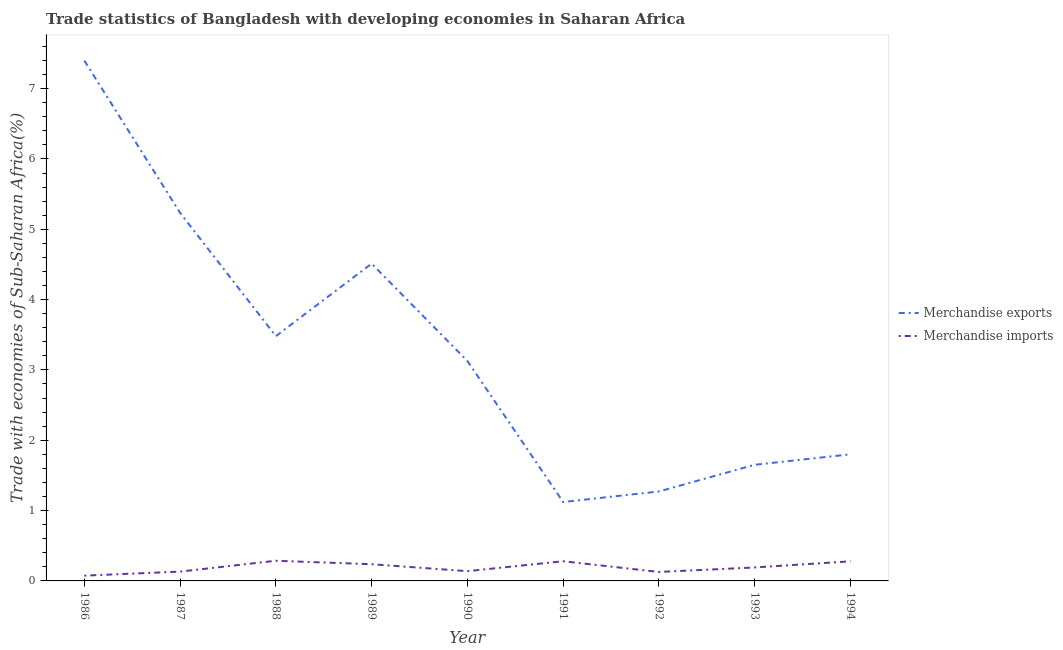How many different coloured lines are there?
Your response must be concise. 2. Does the line corresponding to merchandise imports intersect with the line corresponding to merchandise exports?
Offer a very short reply. No. What is the merchandise imports in 1992?
Offer a very short reply. 0.13. Across all years, what is the maximum merchandise imports?
Make the answer very short. 0.29. Across all years, what is the minimum merchandise imports?
Make the answer very short. 0.08. In which year was the merchandise imports maximum?
Your answer should be compact. 1988. In which year was the merchandise imports minimum?
Make the answer very short. 1986. What is the total merchandise imports in the graph?
Ensure brevity in your answer.  1.75. What is the difference between the merchandise imports in 1989 and that in 1990?
Offer a terse response. 0.1. What is the difference between the merchandise exports in 1988 and the merchandise imports in 1990?
Provide a short and direct response. 3.34. What is the average merchandise exports per year?
Your answer should be compact. 3.29. In the year 1988, what is the difference between the merchandise imports and merchandise exports?
Provide a short and direct response. -3.19. In how many years, is the merchandise imports greater than 1.8 %?
Make the answer very short. 0. What is the ratio of the merchandise exports in 1987 to that in 1988?
Your answer should be very brief. 1.5. Is the merchandise exports in 1990 less than that in 1994?
Your response must be concise. No. Is the difference between the merchandise imports in 1987 and 1993 greater than the difference between the merchandise exports in 1987 and 1993?
Provide a short and direct response. No. What is the difference between the highest and the second highest merchandise exports?
Provide a short and direct response. 2.16. What is the difference between the highest and the lowest merchandise imports?
Offer a very short reply. 0.21. In how many years, is the merchandise imports greater than the average merchandise imports taken over all years?
Ensure brevity in your answer.  4. Is the merchandise imports strictly greater than the merchandise exports over the years?
Ensure brevity in your answer.  No. What is the difference between two consecutive major ticks on the Y-axis?
Provide a short and direct response. 1. Where does the legend appear in the graph?
Your answer should be compact. Center right. How are the legend labels stacked?
Your answer should be compact. Vertical. What is the title of the graph?
Your answer should be very brief. Trade statistics of Bangladesh with developing economies in Saharan Africa. Does "Non-solid fuel" appear as one of the legend labels in the graph?
Ensure brevity in your answer.  No. What is the label or title of the X-axis?
Offer a terse response. Year. What is the label or title of the Y-axis?
Offer a very short reply. Trade with economies of Sub-Saharan Africa(%). What is the Trade with economies of Sub-Saharan Africa(%) of Merchandise exports in 1986?
Provide a short and direct response. 7.4. What is the Trade with economies of Sub-Saharan Africa(%) of Merchandise imports in 1986?
Give a very brief answer. 0.08. What is the Trade with economies of Sub-Saharan Africa(%) of Merchandise exports in 1987?
Provide a short and direct response. 5.23. What is the Trade with economies of Sub-Saharan Africa(%) in Merchandise imports in 1987?
Your answer should be very brief. 0.13. What is the Trade with economies of Sub-Saharan Africa(%) in Merchandise exports in 1988?
Give a very brief answer. 3.48. What is the Trade with economies of Sub-Saharan Africa(%) in Merchandise imports in 1988?
Your response must be concise. 0.29. What is the Trade with economies of Sub-Saharan Africa(%) of Merchandise exports in 1989?
Your answer should be compact. 4.51. What is the Trade with economies of Sub-Saharan Africa(%) of Merchandise imports in 1989?
Keep it short and to the point. 0.24. What is the Trade with economies of Sub-Saharan Africa(%) in Merchandise exports in 1990?
Make the answer very short. 3.13. What is the Trade with economies of Sub-Saharan Africa(%) in Merchandise imports in 1990?
Provide a succinct answer. 0.14. What is the Trade with economies of Sub-Saharan Africa(%) in Merchandise exports in 1991?
Provide a short and direct response. 1.12. What is the Trade with economies of Sub-Saharan Africa(%) in Merchandise imports in 1991?
Ensure brevity in your answer.  0.28. What is the Trade with economies of Sub-Saharan Africa(%) in Merchandise exports in 1992?
Offer a terse response. 1.27. What is the Trade with economies of Sub-Saharan Africa(%) in Merchandise imports in 1992?
Make the answer very short. 0.13. What is the Trade with economies of Sub-Saharan Africa(%) in Merchandise exports in 1993?
Keep it short and to the point. 1.65. What is the Trade with economies of Sub-Saharan Africa(%) in Merchandise imports in 1993?
Keep it short and to the point. 0.19. What is the Trade with economies of Sub-Saharan Africa(%) of Merchandise exports in 1994?
Your answer should be very brief. 1.8. What is the Trade with economies of Sub-Saharan Africa(%) of Merchandise imports in 1994?
Give a very brief answer. 0.28. Across all years, what is the maximum Trade with economies of Sub-Saharan Africa(%) of Merchandise exports?
Make the answer very short. 7.4. Across all years, what is the maximum Trade with economies of Sub-Saharan Africa(%) of Merchandise imports?
Your answer should be very brief. 0.29. Across all years, what is the minimum Trade with economies of Sub-Saharan Africa(%) of Merchandise exports?
Your response must be concise. 1.12. Across all years, what is the minimum Trade with economies of Sub-Saharan Africa(%) of Merchandise imports?
Offer a terse response. 0.08. What is the total Trade with economies of Sub-Saharan Africa(%) of Merchandise exports in the graph?
Your answer should be very brief. 29.6. What is the total Trade with economies of Sub-Saharan Africa(%) of Merchandise imports in the graph?
Keep it short and to the point. 1.75. What is the difference between the Trade with economies of Sub-Saharan Africa(%) of Merchandise exports in 1986 and that in 1987?
Your answer should be compact. 2.16. What is the difference between the Trade with economies of Sub-Saharan Africa(%) in Merchandise imports in 1986 and that in 1987?
Your answer should be compact. -0.06. What is the difference between the Trade with economies of Sub-Saharan Africa(%) in Merchandise exports in 1986 and that in 1988?
Your response must be concise. 3.92. What is the difference between the Trade with economies of Sub-Saharan Africa(%) of Merchandise imports in 1986 and that in 1988?
Provide a succinct answer. -0.21. What is the difference between the Trade with economies of Sub-Saharan Africa(%) of Merchandise exports in 1986 and that in 1989?
Your response must be concise. 2.89. What is the difference between the Trade with economies of Sub-Saharan Africa(%) in Merchandise imports in 1986 and that in 1989?
Offer a very short reply. -0.16. What is the difference between the Trade with economies of Sub-Saharan Africa(%) of Merchandise exports in 1986 and that in 1990?
Your response must be concise. 4.27. What is the difference between the Trade with economies of Sub-Saharan Africa(%) of Merchandise imports in 1986 and that in 1990?
Your answer should be compact. -0.06. What is the difference between the Trade with economies of Sub-Saharan Africa(%) of Merchandise exports in 1986 and that in 1991?
Give a very brief answer. 6.28. What is the difference between the Trade with economies of Sub-Saharan Africa(%) in Merchandise imports in 1986 and that in 1991?
Your response must be concise. -0.2. What is the difference between the Trade with economies of Sub-Saharan Africa(%) of Merchandise exports in 1986 and that in 1992?
Your answer should be compact. 6.13. What is the difference between the Trade with economies of Sub-Saharan Africa(%) of Merchandise imports in 1986 and that in 1992?
Provide a short and direct response. -0.05. What is the difference between the Trade with economies of Sub-Saharan Africa(%) of Merchandise exports in 1986 and that in 1993?
Provide a succinct answer. 5.75. What is the difference between the Trade with economies of Sub-Saharan Africa(%) in Merchandise imports in 1986 and that in 1993?
Provide a succinct answer. -0.12. What is the difference between the Trade with economies of Sub-Saharan Africa(%) of Merchandise exports in 1986 and that in 1994?
Provide a short and direct response. 5.6. What is the difference between the Trade with economies of Sub-Saharan Africa(%) of Merchandise imports in 1986 and that in 1994?
Make the answer very short. -0.2. What is the difference between the Trade with economies of Sub-Saharan Africa(%) of Merchandise exports in 1987 and that in 1988?
Your answer should be very brief. 1.75. What is the difference between the Trade with economies of Sub-Saharan Africa(%) of Merchandise imports in 1987 and that in 1988?
Offer a very short reply. -0.15. What is the difference between the Trade with economies of Sub-Saharan Africa(%) in Merchandise exports in 1987 and that in 1989?
Provide a succinct answer. 0.72. What is the difference between the Trade with economies of Sub-Saharan Africa(%) of Merchandise imports in 1987 and that in 1989?
Keep it short and to the point. -0.1. What is the difference between the Trade with economies of Sub-Saharan Africa(%) of Merchandise exports in 1987 and that in 1990?
Your response must be concise. 2.11. What is the difference between the Trade with economies of Sub-Saharan Africa(%) in Merchandise imports in 1987 and that in 1990?
Your response must be concise. -0.01. What is the difference between the Trade with economies of Sub-Saharan Africa(%) in Merchandise exports in 1987 and that in 1991?
Make the answer very short. 4.11. What is the difference between the Trade with economies of Sub-Saharan Africa(%) of Merchandise imports in 1987 and that in 1991?
Keep it short and to the point. -0.15. What is the difference between the Trade with economies of Sub-Saharan Africa(%) in Merchandise exports in 1987 and that in 1992?
Give a very brief answer. 3.96. What is the difference between the Trade with economies of Sub-Saharan Africa(%) of Merchandise imports in 1987 and that in 1992?
Your answer should be compact. 0.01. What is the difference between the Trade with economies of Sub-Saharan Africa(%) in Merchandise exports in 1987 and that in 1993?
Provide a succinct answer. 3.58. What is the difference between the Trade with economies of Sub-Saharan Africa(%) in Merchandise imports in 1987 and that in 1993?
Give a very brief answer. -0.06. What is the difference between the Trade with economies of Sub-Saharan Africa(%) in Merchandise exports in 1987 and that in 1994?
Offer a very short reply. 3.43. What is the difference between the Trade with economies of Sub-Saharan Africa(%) in Merchandise imports in 1987 and that in 1994?
Ensure brevity in your answer.  -0.15. What is the difference between the Trade with economies of Sub-Saharan Africa(%) in Merchandise exports in 1988 and that in 1989?
Offer a terse response. -1.03. What is the difference between the Trade with economies of Sub-Saharan Africa(%) in Merchandise imports in 1988 and that in 1989?
Offer a terse response. 0.05. What is the difference between the Trade with economies of Sub-Saharan Africa(%) in Merchandise exports in 1988 and that in 1990?
Give a very brief answer. 0.35. What is the difference between the Trade with economies of Sub-Saharan Africa(%) of Merchandise imports in 1988 and that in 1990?
Offer a very short reply. 0.15. What is the difference between the Trade with economies of Sub-Saharan Africa(%) in Merchandise exports in 1988 and that in 1991?
Offer a very short reply. 2.36. What is the difference between the Trade with economies of Sub-Saharan Africa(%) of Merchandise imports in 1988 and that in 1991?
Keep it short and to the point. 0.01. What is the difference between the Trade with economies of Sub-Saharan Africa(%) in Merchandise exports in 1988 and that in 1992?
Your response must be concise. 2.21. What is the difference between the Trade with economies of Sub-Saharan Africa(%) of Merchandise imports in 1988 and that in 1992?
Provide a short and direct response. 0.16. What is the difference between the Trade with economies of Sub-Saharan Africa(%) of Merchandise exports in 1988 and that in 1993?
Offer a terse response. 1.83. What is the difference between the Trade with economies of Sub-Saharan Africa(%) of Merchandise imports in 1988 and that in 1993?
Ensure brevity in your answer.  0.1. What is the difference between the Trade with economies of Sub-Saharan Africa(%) of Merchandise exports in 1988 and that in 1994?
Provide a succinct answer. 1.68. What is the difference between the Trade with economies of Sub-Saharan Africa(%) of Merchandise imports in 1988 and that in 1994?
Keep it short and to the point. 0.01. What is the difference between the Trade with economies of Sub-Saharan Africa(%) in Merchandise exports in 1989 and that in 1990?
Make the answer very short. 1.38. What is the difference between the Trade with economies of Sub-Saharan Africa(%) of Merchandise imports in 1989 and that in 1990?
Keep it short and to the point. 0.1. What is the difference between the Trade with economies of Sub-Saharan Africa(%) in Merchandise exports in 1989 and that in 1991?
Provide a succinct answer. 3.39. What is the difference between the Trade with economies of Sub-Saharan Africa(%) of Merchandise imports in 1989 and that in 1991?
Offer a terse response. -0.04. What is the difference between the Trade with economies of Sub-Saharan Africa(%) in Merchandise exports in 1989 and that in 1992?
Offer a terse response. 3.24. What is the difference between the Trade with economies of Sub-Saharan Africa(%) of Merchandise imports in 1989 and that in 1992?
Ensure brevity in your answer.  0.11. What is the difference between the Trade with economies of Sub-Saharan Africa(%) of Merchandise exports in 1989 and that in 1993?
Make the answer very short. 2.86. What is the difference between the Trade with economies of Sub-Saharan Africa(%) in Merchandise imports in 1989 and that in 1993?
Provide a succinct answer. 0.05. What is the difference between the Trade with economies of Sub-Saharan Africa(%) of Merchandise exports in 1989 and that in 1994?
Ensure brevity in your answer.  2.71. What is the difference between the Trade with economies of Sub-Saharan Africa(%) in Merchandise imports in 1989 and that in 1994?
Keep it short and to the point. -0.04. What is the difference between the Trade with economies of Sub-Saharan Africa(%) in Merchandise exports in 1990 and that in 1991?
Ensure brevity in your answer.  2. What is the difference between the Trade with economies of Sub-Saharan Africa(%) of Merchandise imports in 1990 and that in 1991?
Provide a short and direct response. -0.14. What is the difference between the Trade with economies of Sub-Saharan Africa(%) in Merchandise exports in 1990 and that in 1992?
Keep it short and to the point. 1.85. What is the difference between the Trade with economies of Sub-Saharan Africa(%) in Merchandise imports in 1990 and that in 1992?
Provide a succinct answer. 0.01. What is the difference between the Trade with economies of Sub-Saharan Africa(%) in Merchandise exports in 1990 and that in 1993?
Your answer should be very brief. 1.48. What is the difference between the Trade with economies of Sub-Saharan Africa(%) of Merchandise imports in 1990 and that in 1993?
Offer a very short reply. -0.05. What is the difference between the Trade with economies of Sub-Saharan Africa(%) in Merchandise exports in 1990 and that in 1994?
Provide a succinct answer. 1.33. What is the difference between the Trade with economies of Sub-Saharan Africa(%) of Merchandise imports in 1990 and that in 1994?
Keep it short and to the point. -0.14. What is the difference between the Trade with economies of Sub-Saharan Africa(%) in Merchandise exports in 1991 and that in 1992?
Keep it short and to the point. -0.15. What is the difference between the Trade with economies of Sub-Saharan Africa(%) of Merchandise imports in 1991 and that in 1992?
Ensure brevity in your answer.  0.15. What is the difference between the Trade with economies of Sub-Saharan Africa(%) in Merchandise exports in 1991 and that in 1993?
Offer a terse response. -0.53. What is the difference between the Trade with economies of Sub-Saharan Africa(%) of Merchandise imports in 1991 and that in 1993?
Make the answer very short. 0.09. What is the difference between the Trade with economies of Sub-Saharan Africa(%) in Merchandise exports in 1991 and that in 1994?
Provide a short and direct response. -0.68. What is the difference between the Trade with economies of Sub-Saharan Africa(%) of Merchandise imports in 1991 and that in 1994?
Keep it short and to the point. 0. What is the difference between the Trade with economies of Sub-Saharan Africa(%) of Merchandise exports in 1992 and that in 1993?
Make the answer very short. -0.38. What is the difference between the Trade with economies of Sub-Saharan Africa(%) in Merchandise imports in 1992 and that in 1993?
Keep it short and to the point. -0.06. What is the difference between the Trade with economies of Sub-Saharan Africa(%) of Merchandise exports in 1992 and that in 1994?
Offer a very short reply. -0.53. What is the difference between the Trade with economies of Sub-Saharan Africa(%) in Merchandise imports in 1992 and that in 1994?
Offer a very short reply. -0.15. What is the difference between the Trade with economies of Sub-Saharan Africa(%) of Merchandise exports in 1993 and that in 1994?
Make the answer very short. -0.15. What is the difference between the Trade with economies of Sub-Saharan Africa(%) in Merchandise imports in 1993 and that in 1994?
Provide a short and direct response. -0.09. What is the difference between the Trade with economies of Sub-Saharan Africa(%) of Merchandise exports in 1986 and the Trade with economies of Sub-Saharan Africa(%) of Merchandise imports in 1987?
Offer a terse response. 7.27. What is the difference between the Trade with economies of Sub-Saharan Africa(%) of Merchandise exports in 1986 and the Trade with economies of Sub-Saharan Africa(%) of Merchandise imports in 1988?
Provide a short and direct response. 7.11. What is the difference between the Trade with economies of Sub-Saharan Africa(%) of Merchandise exports in 1986 and the Trade with economies of Sub-Saharan Africa(%) of Merchandise imports in 1989?
Offer a terse response. 7.16. What is the difference between the Trade with economies of Sub-Saharan Africa(%) of Merchandise exports in 1986 and the Trade with economies of Sub-Saharan Africa(%) of Merchandise imports in 1990?
Provide a short and direct response. 7.26. What is the difference between the Trade with economies of Sub-Saharan Africa(%) of Merchandise exports in 1986 and the Trade with economies of Sub-Saharan Africa(%) of Merchandise imports in 1991?
Your answer should be very brief. 7.12. What is the difference between the Trade with economies of Sub-Saharan Africa(%) of Merchandise exports in 1986 and the Trade with economies of Sub-Saharan Africa(%) of Merchandise imports in 1992?
Provide a short and direct response. 7.27. What is the difference between the Trade with economies of Sub-Saharan Africa(%) in Merchandise exports in 1986 and the Trade with economies of Sub-Saharan Africa(%) in Merchandise imports in 1993?
Provide a succinct answer. 7.21. What is the difference between the Trade with economies of Sub-Saharan Africa(%) of Merchandise exports in 1986 and the Trade with economies of Sub-Saharan Africa(%) of Merchandise imports in 1994?
Ensure brevity in your answer.  7.12. What is the difference between the Trade with economies of Sub-Saharan Africa(%) in Merchandise exports in 1987 and the Trade with economies of Sub-Saharan Africa(%) in Merchandise imports in 1988?
Offer a very short reply. 4.95. What is the difference between the Trade with economies of Sub-Saharan Africa(%) in Merchandise exports in 1987 and the Trade with economies of Sub-Saharan Africa(%) in Merchandise imports in 1989?
Your answer should be compact. 5. What is the difference between the Trade with economies of Sub-Saharan Africa(%) in Merchandise exports in 1987 and the Trade with economies of Sub-Saharan Africa(%) in Merchandise imports in 1990?
Provide a short and direct response. 5.09. What is the difference between the Trade with economies of Sub-Saharan Africa(%) in Merchandise exports in 1987 and the Trade with economies of Sub-Saharan Africa(%) in Merchandise imports in 1991?
Provide a succinct answer. 4.95. What is the difference between the Trade with economies of Sub-Saharan Africa(%) in Merchandise exports in 1987 and the Trade with economies of Sub-Saharan Africa(%) in Merchandise imports in 1992?
Your answer should be compact. 5.11. What is the difference between the Trade with economies of Sub-Saharan Africa(%) of Merchandise exports in 1987 and the Trade with economies of Sub-Saharan Africa(%) of Merchandise imports in 1993?
Keep it short and to the point. 5.04. What is the difference between the Trade with economies of Sub-Saharan Africa(%) of Merchandise exports in 1987 and the Trade with economies of Sub-Saharan Africa(%) of Merchandise imports in 1994?
Your answer should be compact. 4.95. What is the difference between the Trade with economies of Sub-Saharan Africa(%) in Merchandise exports in 1988 and the Trade with economies of Sub-Saharan Africa(%) in Merchandise imports in 1989?
Give a very brief answer. 3.24. What is the difference between the Trade with economies of Sub-Saharan Africa(%) in Merchandise exports in 1988 and the Trade with economies of Sub-Saharan Africa(%) in Merchandise imports in 1990?
Your response must be concise. 3.34. What is the difference between the Trade with economies of Sub-Saharan Africa(%) in Merchandise exports in 1988 and the Trade with economies of Sub-Saharan Africa(%) in Merchandise imports in 1991?
Offer a very short reply. 3.2. What is the difference between the Trade with economies of Sub-Saharan Africa(%) of Merchandise exports in 1988 and the Trade with economies of Sub-Saharan Africa(%) of Merchandise imports in 1992?
Your answer should be compact. 3.35. What is the difference between the Trade with economies of Sub-Saharan Africa(%) of Merchandise exports in 1988 and the Trade with economies of Sub-Saharan Africa(%) of Merchandise imports in 1993?
Your answer should be very brief. 3.29. What is the difference between the Trade with economies of Sub-Saharan Africa(%) in Merchandise exports in 1988 and the Trade with economies of Sub-Saharan Africa(%) in Merchandise imports in 1994?
Your answer should be compact. 3.2. What is the difference between the Trade with economies of Sub-Saharan Africa(%) of Merchandise exports in 1989 and the Trade with economies of Sub-Saharan Africa(%) of Merchandise imports in 1990?
Your answer should be compact. 4.37. What is the difference between the Trade with economies of Sub-Saharan Africa(%) in Merchandise exports in 1989 and the Trade with economies of Sub-Saharan Africa(%) in Merchandise imports in 1991?
Give a very brief answer. 4.23. What is the difference between the Trade with economies of Sub-Saharan Africa(%) of Merchandise exports in 1989 and the Trade with economies of Sub-Saharan Africa(%) of Merchandise imports in 1992?
Keep it short and to the point. 4.38. What is the difference between the Trade with economies of Sub-Saharan Africa(%) in Merchandise exports in 1989 and the Trade with economies of Sub-Saharan Africa(%) in Merchandise imports in 1993?
Make the answer very short. 4.32. What is the difference between the Trade with economies of Sub-Saharan Africa(%) of Merchandise exports in 1989 and the Trade with economies of Sub-Saharan Africa(%) of Merchandise imports in 1994?
Provide a succinct answer. 4.23. What is the difference between the Trade with economies of Sub-Saharan Africa(%) of Merchandise exports in 1990 and the Trade with economies of Sub-Saharan Africa(%) of Merchandise imports in 1991?
Offer a terse response. 2.85. What is the difference between the Trade with economies of Sub-Saharan Africa(%) of Merchandise exports in 1990 and the Trade with economies of Sub-Saharan Africa(%) of Merchandise imports in 1992?
Provide a short and direct response. 3. What is the difference between the Trade with economies of Sub-Saharan Africa(%) of Merchandise exports in 1990 and the Trade with economies of Sub-Saharan Africa(%) of Merchandise imports in 1993?
Offer a terse response. 2.94. What is the difference between the Trade with economies of Sub-Saharan Africa(%) of Merchandise exports in 1990 and the Trade with economies of Sub-Saharan Africa(%) of Merchandise imports in 1994?
Offer a very short reply. 2.85. What is the difference between the Trade with economies of Sub-Saharan Africa(%) in Merchandise exports in 1991 and the Trade with economies of Sub-Saharan Africa(%) in Merchandise imports in 1992?
Provide a succinct answer. 0.99. What is the difference between the Trade with economies of Sub-Saharan Africa(%) in Merchandise exports in 1991 and the Trade with economies of Sub-Saharan Africa(%) in Merchandise imports in 1993?
Give a very brief answer. 0.93. What is the difference between the Trade with economies of Sub-Saharan Africa(%) in Merchandise exports in 1991 and the Trade with economies of Sub-Saharan Africa(%) in Merchandise imports in 1994?
Ensure brevity in your answer.  0.84. What is the difference between the Trade with economies of Sub-Saharan Africa(%) in Merchandise exports in 1992 and the Trade with economies of Sub-Saharan Africa(%) in Merchandise imports in 1993?
Your answer should be compact. 1.08. What is the difference between the Trade with economies of Sub-Saharan Africa(%) in Merchandise exports in 1993 and the Trade with economies of Sub-Saharan Africa(%) in Merchandise imports in 1994?
Offer a very short reply. 1.37. What is the average Trade with economies of Sub-Saharan Africa(%) in Merchandise exports per year?
Provide a succinct answer. 3.29. What is the average Trade with economies of Sub-Saharan Africa(%) in Merchandise imports per year?
Ensure brevity in your answer.  0.19. In the year 1986, what is the difference between the Trade with economies of Sub-Saharan Africa(%) of Merchandise exports and Trade with economies of Sub-Saharan Africa(%) of Merchandise imports?
Offer a terse response. 7.32. In the year 1987, what is the difference between the Trade with economies of Sub-Saharan Africa(%) in Merchandise exports and Trade with economies of Sub-Saharan Africa(%) in Merchandise imports?
Your answer should be compact. 5.1. In the year 1988, what is the difference between the Trade with economies of Sub-Saharan Africa(%) of Merchandise exports and Trade with economies of Sub-Saharan Africa(%) of Merchandise imports?
Offer a very short reply. 3.19. In the year 1989, what is the difference between the Trade with economies of Sub-Saharan Africa(%) in Merchandise exports and Trade with economies of Sub-Saharan Africa(%) in Merchandise imports?
Give a very brief answer. 4.27. In the year 1990, what is the difference between the Trade with economies of Sub-Saharan Africa(%) in Merchandise exports and Trade with economies of Sub-Saharan Africa(%) in Merchandise imports?
Provide a short and direct response. 2.99. In the year 1991, what is the difference between the Trade with economies of Sub-Saharan Africa(%) in Merchandise exports and Trade with economies of Sub-Saharan Africa(%) in Merchandise imports?
Provide a succinct answer. 0.84. In the year 1992, what is the difference between the Trade with economies of Sub-Saharan Africa(%) in Merchandise exports and Trade with economies of Sub-Saharan Africa(%) in Merchandise imports?
Keep it short and to the point. 1.14. In the year 1993, what is the difference between the Trade with economies of Sub-Saharan Africa(%) in Merchandise exports and Trade with economies of Sub-Saharan Africa(%) in Merchandise imports?
Your answer should be compact. 1.46. In the year 1994, what is the difference between the Trade with economies of Sub-Saharan Africa(%) in Merchandise exports and Trade with economies of Sub-Saharan Africa(%) in Merchandise imports?
Keep it short and to the point. 1.52. What is the ratio of the Trade with economies of Sub-Saharan Africa(%) in Merchandise exports in 1986 to that in 1987?
Your response must be concise. 1.41. What is the ratio of the Trade with economies of Sub-Saharan Africa(%) in Merchandise imports in 1986 to that in 1987?
Give a very brief answer. 0.57. What is the ratio of the Trade with economies of Sub-Saharan Africa(%) in Merchandise exports in 1986 to that in 1988?
Give a very brief answer. 2.13. What is the ratio of the Trade with economies of Sub-Saharan Africa(%) of Merchandise imports in 1986 to that in 1988?
Your answer should be compact. 0.26. What is the ratio of the Trade with economies of Sub-Saharan Africa(%) in Merchandise exports in 1986 to that in 1989?
Offer a very short reply. 1.64. What is the ratio of the Trade with economies of Sub-Saharan Africa(%) in Merchandise imports in 1986 to that in 1989?
Provide a short and direct response. 0.32. What is the ratio of the Trade with economies of Sub-Saharan Africa(%) in Merchandise exports in 1986 to that in 1990?
Offer a terse response. 2.37. What is the ratio of the Trade with economies of Sub-Saharan Africa(%) in Merchandise imports in 1986 to that in 1990?
Keep it short and to the point. 0.54. What is the ratio of the Trade with economies of Sub-Saharan Africa(%) in Merchandise exports in 1986 to that in 1991?
Keep it short and to the point. 6.59. What is the ratio of the Trade with economies of Sub-Saharan Africa(%) of Merchandise imports in 1986 to that in 1991?
Your answer should be compact. 0.27. What is the ratio of the Trade with economies of Sub-Saharan Africa(%) of Merchandise exports in 1986 to that in 1992?
Your response must be concise. 5.82. What is the ratio of the Trade with economies of Sub-Saharan Africa(%) in Merchandise imports in 1986 to that in 1992?
Provide a short and direct response. 0.59. What is the ratio of the Trade with economies of Sub-Saharan Africa(%) of Merchandise exports in 1986 to that in 1993?
Offer a terse response. 4.48. What is the ratio of the Trade with economies of Sub-Saharan Africa(%) in Merchandise imports in 1986 to that in 1993?
Make the answer very short. 0.39. What is the ratio of the Trade with economies of Sub-Saharan Africa(%) in Merchandise exports in 1986 to that in 1994?
Keep it short and to the point. 4.11. What is the ratio of the Trade with economies of Sub-Saharan Africa(%) in Merchandise imports in 1986 to that in 1994?
Provide a short and direct response. 0.27. What is the ratio of the Trade with economies of Sub-Saharan Africa(%) in Merchandise exports in 1987 to that in 1988?
Provide a short and direct response. 1.5. What is the ratio of the Trade with economies of Sub-Saharan Africa(%) in Merchandise imports in 1987 to that in 1988?
Your response must be concise. 0.46. What is the ratio of the Trade with economies of Sub-Saharan Africa(%) in Merchandise exports in 1987 to that in 1989?
Your response must be concise. 1.16. What is the ratio of the Trade with economies of Sub-Saharan Africa(%) of Merchandise imports in 1987 to that in 1989?
Give a very brief answer. 0.56. What is the ratio of the Trade with economies of Sub-Saharan Africa(%) of Merchandise exports in 1987 to that in 1990?
Ensure brevity in your answer.  1.67. What is the ratio of the Trade with economies of Sub-Saharan Africa(%) of Merchandise imports in 1987 to that in 1990?
Give a very brief answer. 0.95. What is the ratio of the Trade with economies of Sub-Saharan Africa(%) of Merchandise exports in 1987 to that in 1991?
Provide a short and direct response. 4.66. What is the ratio of the Trade with economies of Sub-Saharan Africa(%) in Merchandise imports in 1987 to that in 1991?
Provide a succinct answer. 0.47. What is the ratio of the Trade with economies of Sub-Saharan Africa(%) of Merchandise exports in 1987 to that in 1992?
Your response must be concise. 4.11. What is the ratio of the Trade with economies of Sub-Saharan Africa(%) of Merchandise imports in 1987 to that in 1992?
Your answer should be very brief. 1.04. What is the ratio of the Trade with economies of Sub-Saharan Africa(%) of Merchandise exports in 1987 to that in 1993?
Your answer should be compact. 3.17. What is the ratio of the Trade with economies of Sub-Saharan Africa(%) in Merchandise imports in 1987 to that in 1993?
Provide a succinct answer. 0.69. What is the ratio of the Trade with economies of Sub-Saharan Africa(%) of Merchandise exports in 1987 to that in 1994?
Offer a very short reply. 2.91. What is the ratio of the Trade with economies of Sub-Saharan Africa(%) in Merchandise imports in 1987 to that in 1994?
Make the answer very short. 0.48. What is the ratio of the Trade with economies of Sub-Saharan Africa(%) in Merchandise exports in 1988 to that in 1989?
Provide a succinct answer. 0.77. What is the ratio of the Trade with economies of Sub-Saharan Africa(%) of Merchandise imports in 1988 to that in 1989?
Your answer should be compact. 1.21. What is the ratio of the Trade with economies of Sub-Saharan Africa(%) in Merchandise exports in 1988 to that in 1990?
Make the answer very short. 1.11. What is the ratio of the Trade with economies of Sub-Saharan Africa(%) in Merchandise imports in 1988 to that in 1990?
Offer a terse response. 2.07. What is the ratio of the Trade with economies of Sub-Saharan Africa(%) in Merchandise exports in 1988 to that in 1991?
Your response must be concise. 3.1. What is the ratio of the Trade with economies of Sub-Saharan Africa(%) in Merchandise imports in 1988 to that in 1991?
Provide a succinct answer. 1.02. What is the ratio of the Trade with economies of Sub-Saharan Africa(%) in Merchandise exports in 1988 to that in 1992?
Your response must be concise. 2.74. What is the ratio of the Trade with economies of Sub-Saharan Africa(%) in Merchandise imports in 1988 to that in 1992?
Ensure brevity in your answer.  2.25. What is the ratio of the Trade with economies of Sub-Saharan Africa(%) of Merchandise exports in 1988 to that in 1993?
Keep it short and to the point. 2.11. What is the ratio of the Trade with economies of Sub-Saharan Africa(%) in Merchandise imports in 1988 to that in 1993?
Provide a succinct answer. 1.5. What is the ratio of the Trade with economies of Sub-Saharan Africa(%) in Merchandise exports in 1988 to that in 1994?
Offer a very short reply. 1.93. What is the ratio of the Trade with economies of Sub-Saharan Africa(%) of Merchandise imports in 1988 to that in 1994?
Offer a very short reply. 1.03. What is the ratio of the Trade with economies of Sub-Saharan Africa(%) of Merchandise exports in 1989 to that in 1990?
Your answer should be compact. 1.44. What is the ratio of the Trade with economies of Sub-Saharan Africa(%) in Merchandise imports in 1989 to that in 1990?
Your answer should be very brief. 1.71. What is the ratio of the Trade with economies of Sub-Saharan Africa(%) of Merchandise exports in 1989 to that in 1991?
Provide a short and direct response. 4.02. What is the ratio of the Trade with economies of Sub-Saharan Africa(%) of Merchandise imports in 1989 to that in 1991?
Offer a very short reply. 0.85. What is the ratio of the Trade with economies of Sub-Saharan Africa(%) of Merchandise exports in 1989 to that in 1992?
Ensure brevity in your answer.  3.55. What is the ratio of the Trade with economies of Sub-Saharan Africa(%) of Merchandise imports in 1989 to that in 1992?
Ensure brevity in your answer.  1.86. What is the ratio of the Trade with economies of Sub-Saharan Africa(%) in Merchandise exports in 1989 to that in 1993?
Keep it short and to the point. 2.73. What is the ratio of the Trade with economies of Sub-Saharan Africa(%) of Merchandise imports in 1989 to that in 1993?
Your answer should be compact. 1.24. What is the ratio of the Trade with economies of Sub-Saharan Africa(%) in Merchandise exports in 1989 to that in 1994?
Make the answer very short. 2.51. What is the ratio of the Trade with economies of Sub-Saharan Africa(%) in Merchandise imports in 1989 to that in 1994?
Give a very brief answer. 0.85. What is the ratio of the Trade with economies of Sub-Saharan Africa(%) in Merchandise exports in 1990 to that in 1991?
Keep it short and to the point. 2.79. What is the ratio of the Trade with economies of Sub-Saharan Africa(%) of Merchandise imports in 1990 to that in 1991?
Your answer should be compact. 0.5. What is the ratio of the Trade with economies of Sub-Saharan Africa(%) in Merchandise exports in 1990 to that in 1992?
Offer a terse response. 2.46. What is the ratio of the Trade with economies of Sub-Saharan Africa(%) in Merchandise imports in 1990 to that in 1992?
Your answer should be compact. 1.09. What is the ratio of the Trade with economies of Sub-Saharan Africa(%) in Merchandise exports in 1990 to that in 1993?
Your response must be concise. 1.89. What is the ratio of the Trade with economies of Sub-Saharan Africa(%) of Merchandise imports in 1990 to that in 1993?
Your response must be concise. 0.72. What is the ratio of the Trade with economies of Sub-Saharan Africa(%) of Merchandise exports in 1990 to that in 1994?
Your answer should be compact. 1.74. What is the ratio of the Trade with economies of Sub-Saharan Africa(%) of Merchandise imports in 1990 to that in 1994?
Your response must be concise. 0.5. What is the ratio of the Trade with economies of Sub-Saharan Africa(%) in Merchandise exports in 1991 to that in 1992?
Keep it short and to the point. 0.88. What is the ratio of the Trade with economies of Sub-Saharan Africa(%) of Merchandise imports in 1991 to that in 1992?
Your answer should be compact. 2.2. What is the ratio of the Trade with economies of Sub-Saharan Africa(%) of Merchandise exports in 1991 to that in 1993?
Ensure brevity in your answer.  0.68. What is the ratio of the Trade with economies of Sub-Saharan Africa(%) of Merchandise imports in 1991 to that in 1993?
Ensure brevity in your answer.  1.46. What is the ratio of the Trade with economies of Sub-Saharan Africa(%) in Merchandise exports in 1991 to that in 1994?
Your response must be concise. 0.62. What is the ratio of the Trade with economies of Sub-Saharan Africa(%) of Merchandise imports in 1991 to that in 1994?
Provide a succinct answer. 1. What is the ratio of the Trade with economies of Sub-Saharan Africa(%) in Merchandise exports in 1992 to that in 1993?
Provide a short and direct response. 0.77. What is the ratio of the Trade with economies of Sub-Saharan Africa(%) in Merchandise imports in 1992 to that in 1993?
Offer a terse response. 0.67. What is the ratio of the Trade with economies of Sub-Saharan Africa(%) in Merchandise exports in 1992 to that in 1994?
Your answer should be compact. 0.71. What is the ratio of the Trade with economies of Sub-Saharan Africa(%) of Merchandise imports in 1992 to that in 1994?
Keep it short and to the point. 0.46. What is the ratio of the Trade with economies of Sub-Saharan Africa(%) of Merchandise exports in 1993 to that in 1994?
Offer a terse response. 0.92. What is the ratio of the Trade with economies of Sub-Saharan Africa(%) of Merchandise imports in 1993 to that in 1994?
Offer a very short reply. 0.69. What is the difference between the highest and the second highest Trade with economies of Sub-Saharan Africa(%) of Merchandise exports?
Give a very brief answer. 2.16. What is the difference between the highest and the second highest Trade with economies of Sub-Saharan Africa(%) of Merchandise imports?
Provide a short and direct response. 0.01. What is the difference between the highest and the lowest Trade with economies of Sub-Saharan Africa(%) in Merchandise exports?
Your response must be concise. 6.28. What is the difference between the highest and the lowest Trade with economies of Sub-Saharan Africa(%) in Merchandise imports?
Your answer should be compact. 0.21. 